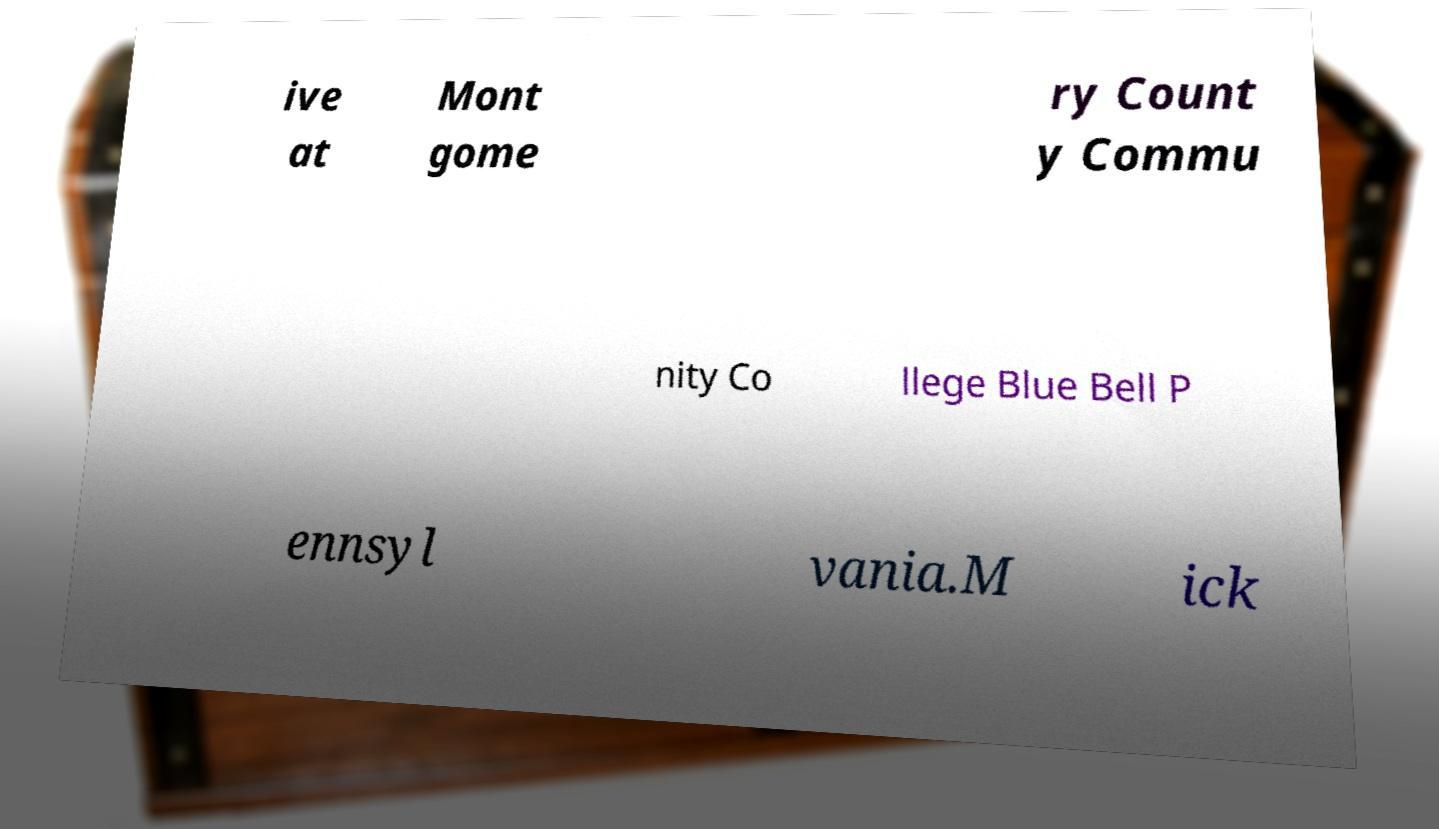What messages or text are displayed in this image? I need them in a readable, typed format. ive at Mont gome ry Count y Commu nity Co llege Blue Bell P ennsyl vania.M ick 